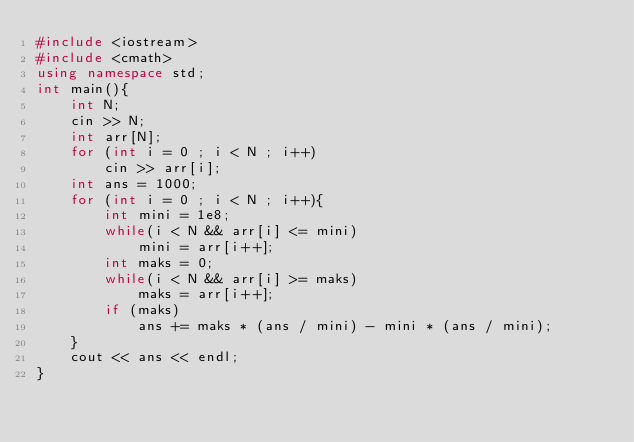Convert code to text. <code><loc_0><loc_0><loc_500><loc_500><_C++_>#include <iostream>
#include <cmath>
using namespace std;
int main(){
    int N;
    cin >> N;
    int arr[N];
    for (int i = 0 ; i < N ; i++)
        cin >> arr[i];
    int ans = 1000;
    for (int i = 0 ; i < N ; i++){
        int mini = 1e8;
        while(i < N && arr[i] <= mini)
            mini = arr[i++];
        int maks = 0;
        while(i < N && arr[i] >= maks)
            maks = arr[i++];
        if (maks)
            ans += maks * (ans / mini) - mini * (ans / mini);
    }
    cout << ans << endl;
}
</code> 